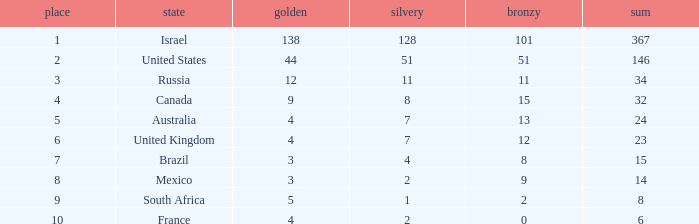What is the maximum number of silvers for a country with fewer than 12 golds and a total less than 8? 2.0. 